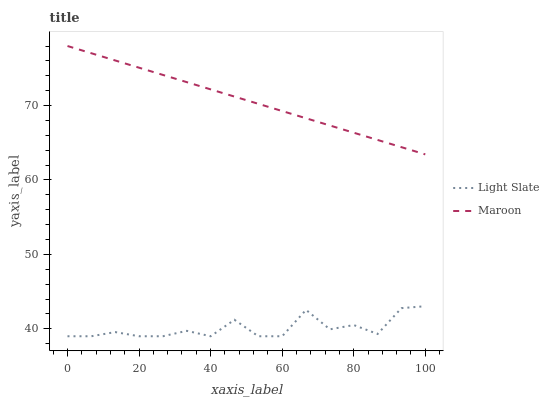Does Light Slate have the minimum area under the curve?
Answer yes or no. Yes. Does Maroon have the maximum area under the curve?
Answer yes or no. Yes. Does Maroon have the minimum area under the curve?
Answer yes or no. No. Is Maroon the smoothest?
Answer yes or no. Yes. Is Light Slate the roughest?
Answer yes or no. Yes. Is Maroon the roughest?
Answer yes or no. No. Does Light Slate have the lowest value?
Answer yes or no. Yes. Does Maroon have the lowest value?
Answer yes or no. No. Does Maroon have the highest value?
Answer yes or no. Yes. Is Light Slate less than Maroon?
Answer yes or no. Yes. Is Maroon greater than Light Slate?
Answer yes or no. Yes. Does Light Slate intersect Maroon?
Answer yes or no. No. 